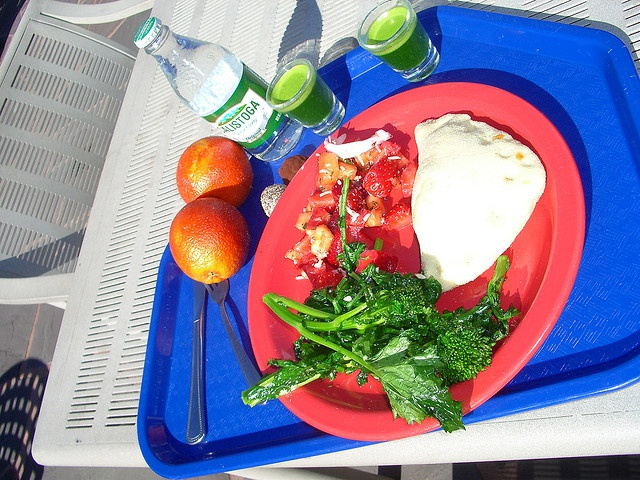Describe the objects in this image and their specific colors. I can see dining table in lightgray, black, blue, salmon, and darkblue tones, chair in black, darkgray, lightgray, and gray tones, broccoli in black, darkgreen, and green tones, bottle in black, white, darkgray, lightblue, and gray tones, and orange in black, red, brown, and orange tones in this image. 